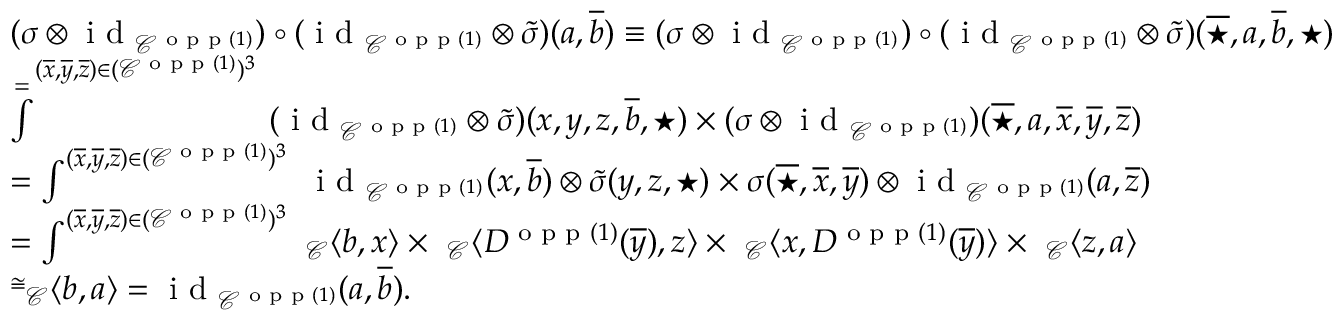<formula> <loc_0><loc_0><loc_500><loc_500>\begin{array} { r l } & { ( \sigma \otimes i d _ { \mathcal { C } ^ { o p p ( 1 ) } } ) \circ ( i d _ { \mathcal { C } ^ { o p p ( 1 ) } } \otimes \tilde { \sigma } ) ( a , \overline { b } ) \equiv ( \sigma \otimes i d _ { \mathcal { C } ^ { o p p ( 1 ) } } ) \circ ( i d _ { \mathcal { C } ^ { o p p ( 1 ) } } \otimes \tilde { \sigma } ) ( \overline { ^ { * } } , a , \overline { b } , ^ { * } ) } \\ & { \overset { = } \int ^ { ( \overline { x } , \overline { y } , \overline { z } ) \in ( \mathcal { C } ^ { o p p ( 1 ) } ) ^ { 3 } } \ ( i d _ { \mathcal { C } ^ { o p p ( 1 ) } } \otimes \tilde { \sigma } ) ( x , y , z , \overline { b } , ^ { * } ) \times ( \sigma \otimes i d _ { \mathcal { C } ^ { o p p ( 1 ) } } ) ( \overline { ^ { * } } , a , \overline { x } , \overline { y } , \overline { z } ) } \\ & { = \int ^ { ( \overline { x } , \overline { y } , \overline { z } ) \in ( \mathcal { C } ^ { o p p ( 1 ) } ) ^ { 3 } } \ i d _ { \mathcal { C } ^ { o p p ( 1 ) } } ( x , \overline { b } ) \otimes \tilde { \sigma } ( y , z , ^ { * } ) \times \sigma ( \overline { ^ { * } } , \overline { x } , \overline { y } ) \otimes i d _ { \mathcal { C } ^ { o p p ( 1 ) } } ( a , \overline { z } ) } \\ & { = \int ^ { ( \overline { x } , \overline { y } , \overline { z } ) \in ( \mathcal { C } ^ { o p p ( 1 ) } ) ^ { 3 } } \ _ { \mathcal { C } } \langle b , x \rangle \times \ _ { \mathcal { C } } \langle D ^ { o p p ( 1 ) } ( \overline { y } ) , z \rangle \times \ _ { \mathcal { C } } \langle x , D ^ { o p p ( 1 ) } ( \overline { y } ) \rangle \times \ _ { \mathcal { C } } \langle z , a \rangle } \\ & { \overset { \cong } \ _ { \mathcal { C } } \langle b , a \rangle = i d _ { \mathcal { C } ^ { o p p ( 1 ) } } ( a , \overline { b } ) . } \end{array}</formula> 